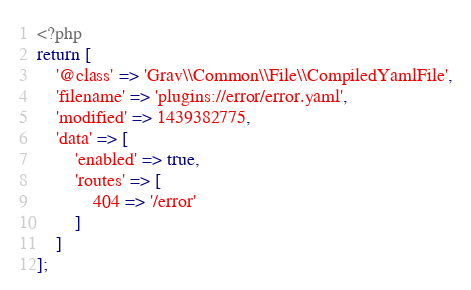<code> <loc_0><loc_0><loc_500><loc_500><_PHP_><?php
return [
    '@class' => 'Grav\\Common\\File\\CompiledYamlFile',
    'filename' => 'plugins://error/error.yaml',
    'modified' => 1439382775,
    'data' => [
        'enabled' => true,
        'routes' => [
            404 => '/error'
        ]
    ]
];
</code> 